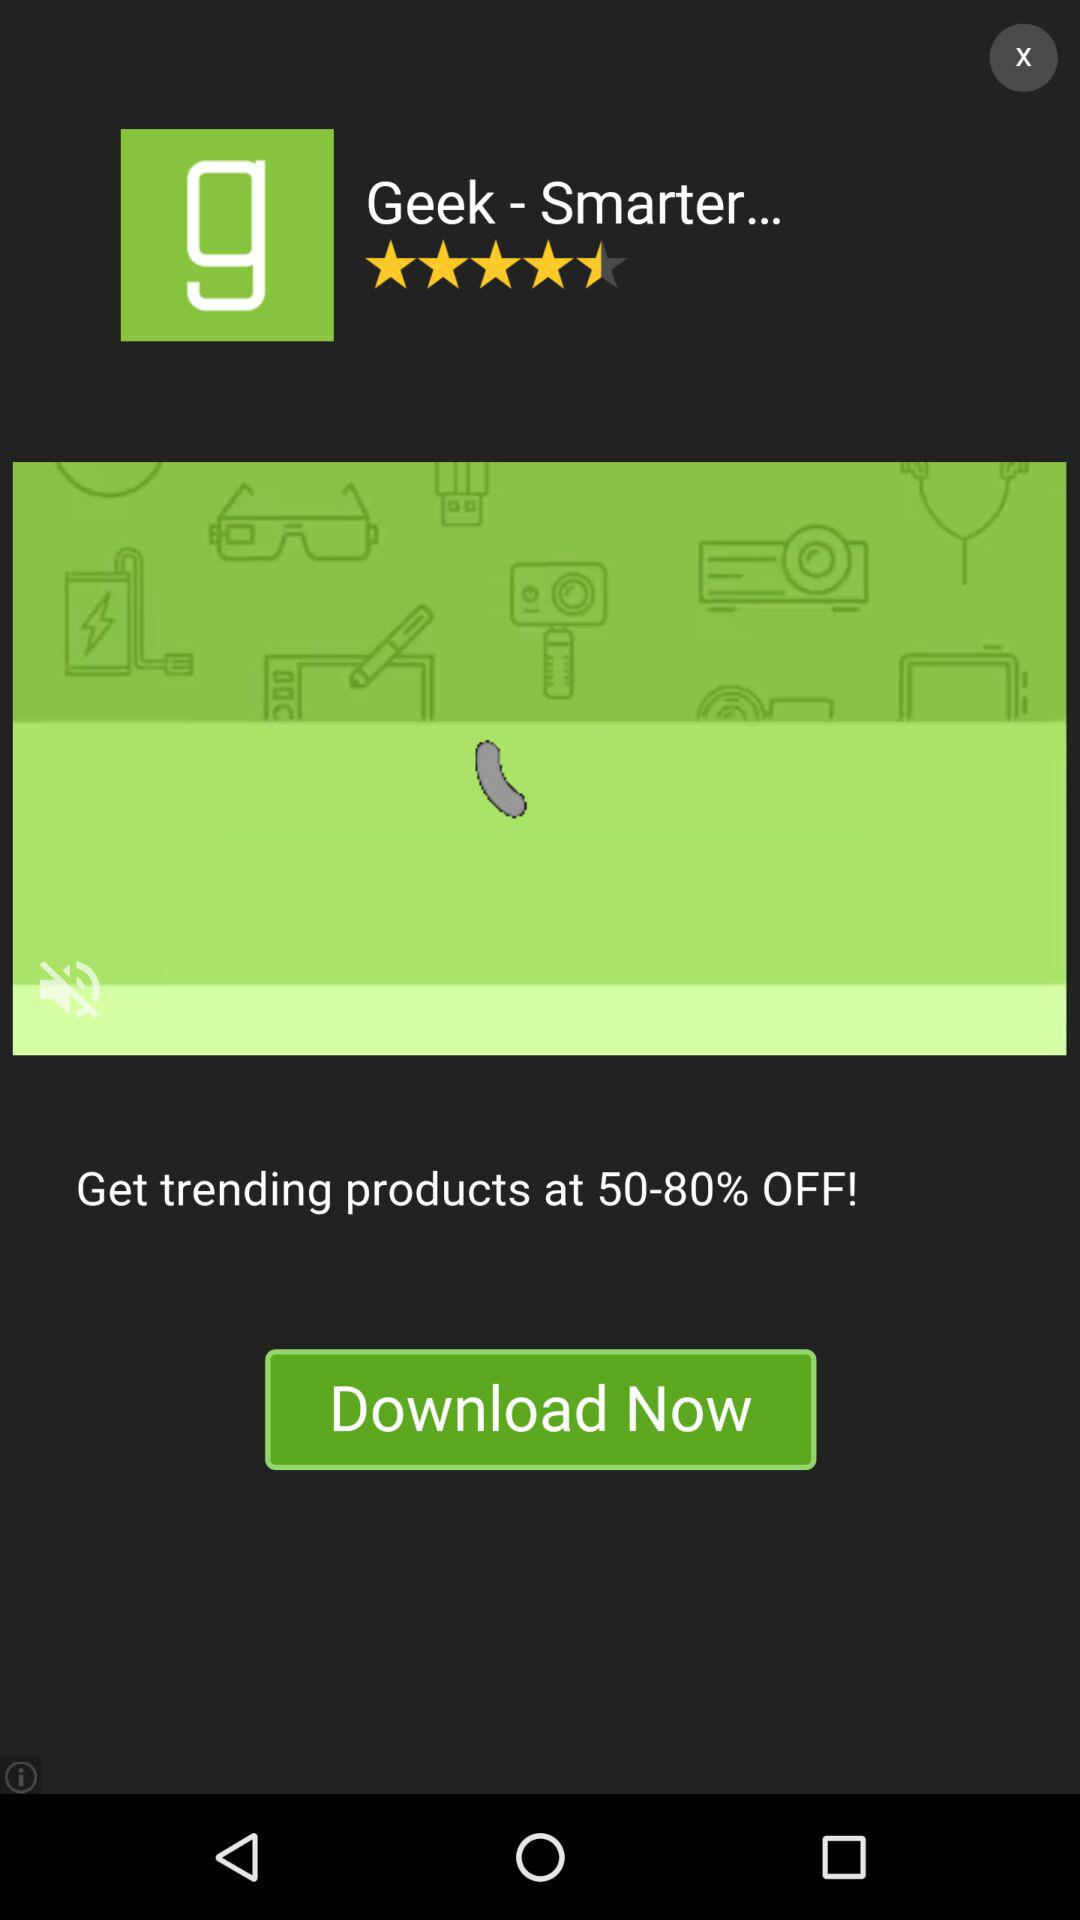What is the application name? The application name is "Geek - Smarter...". 